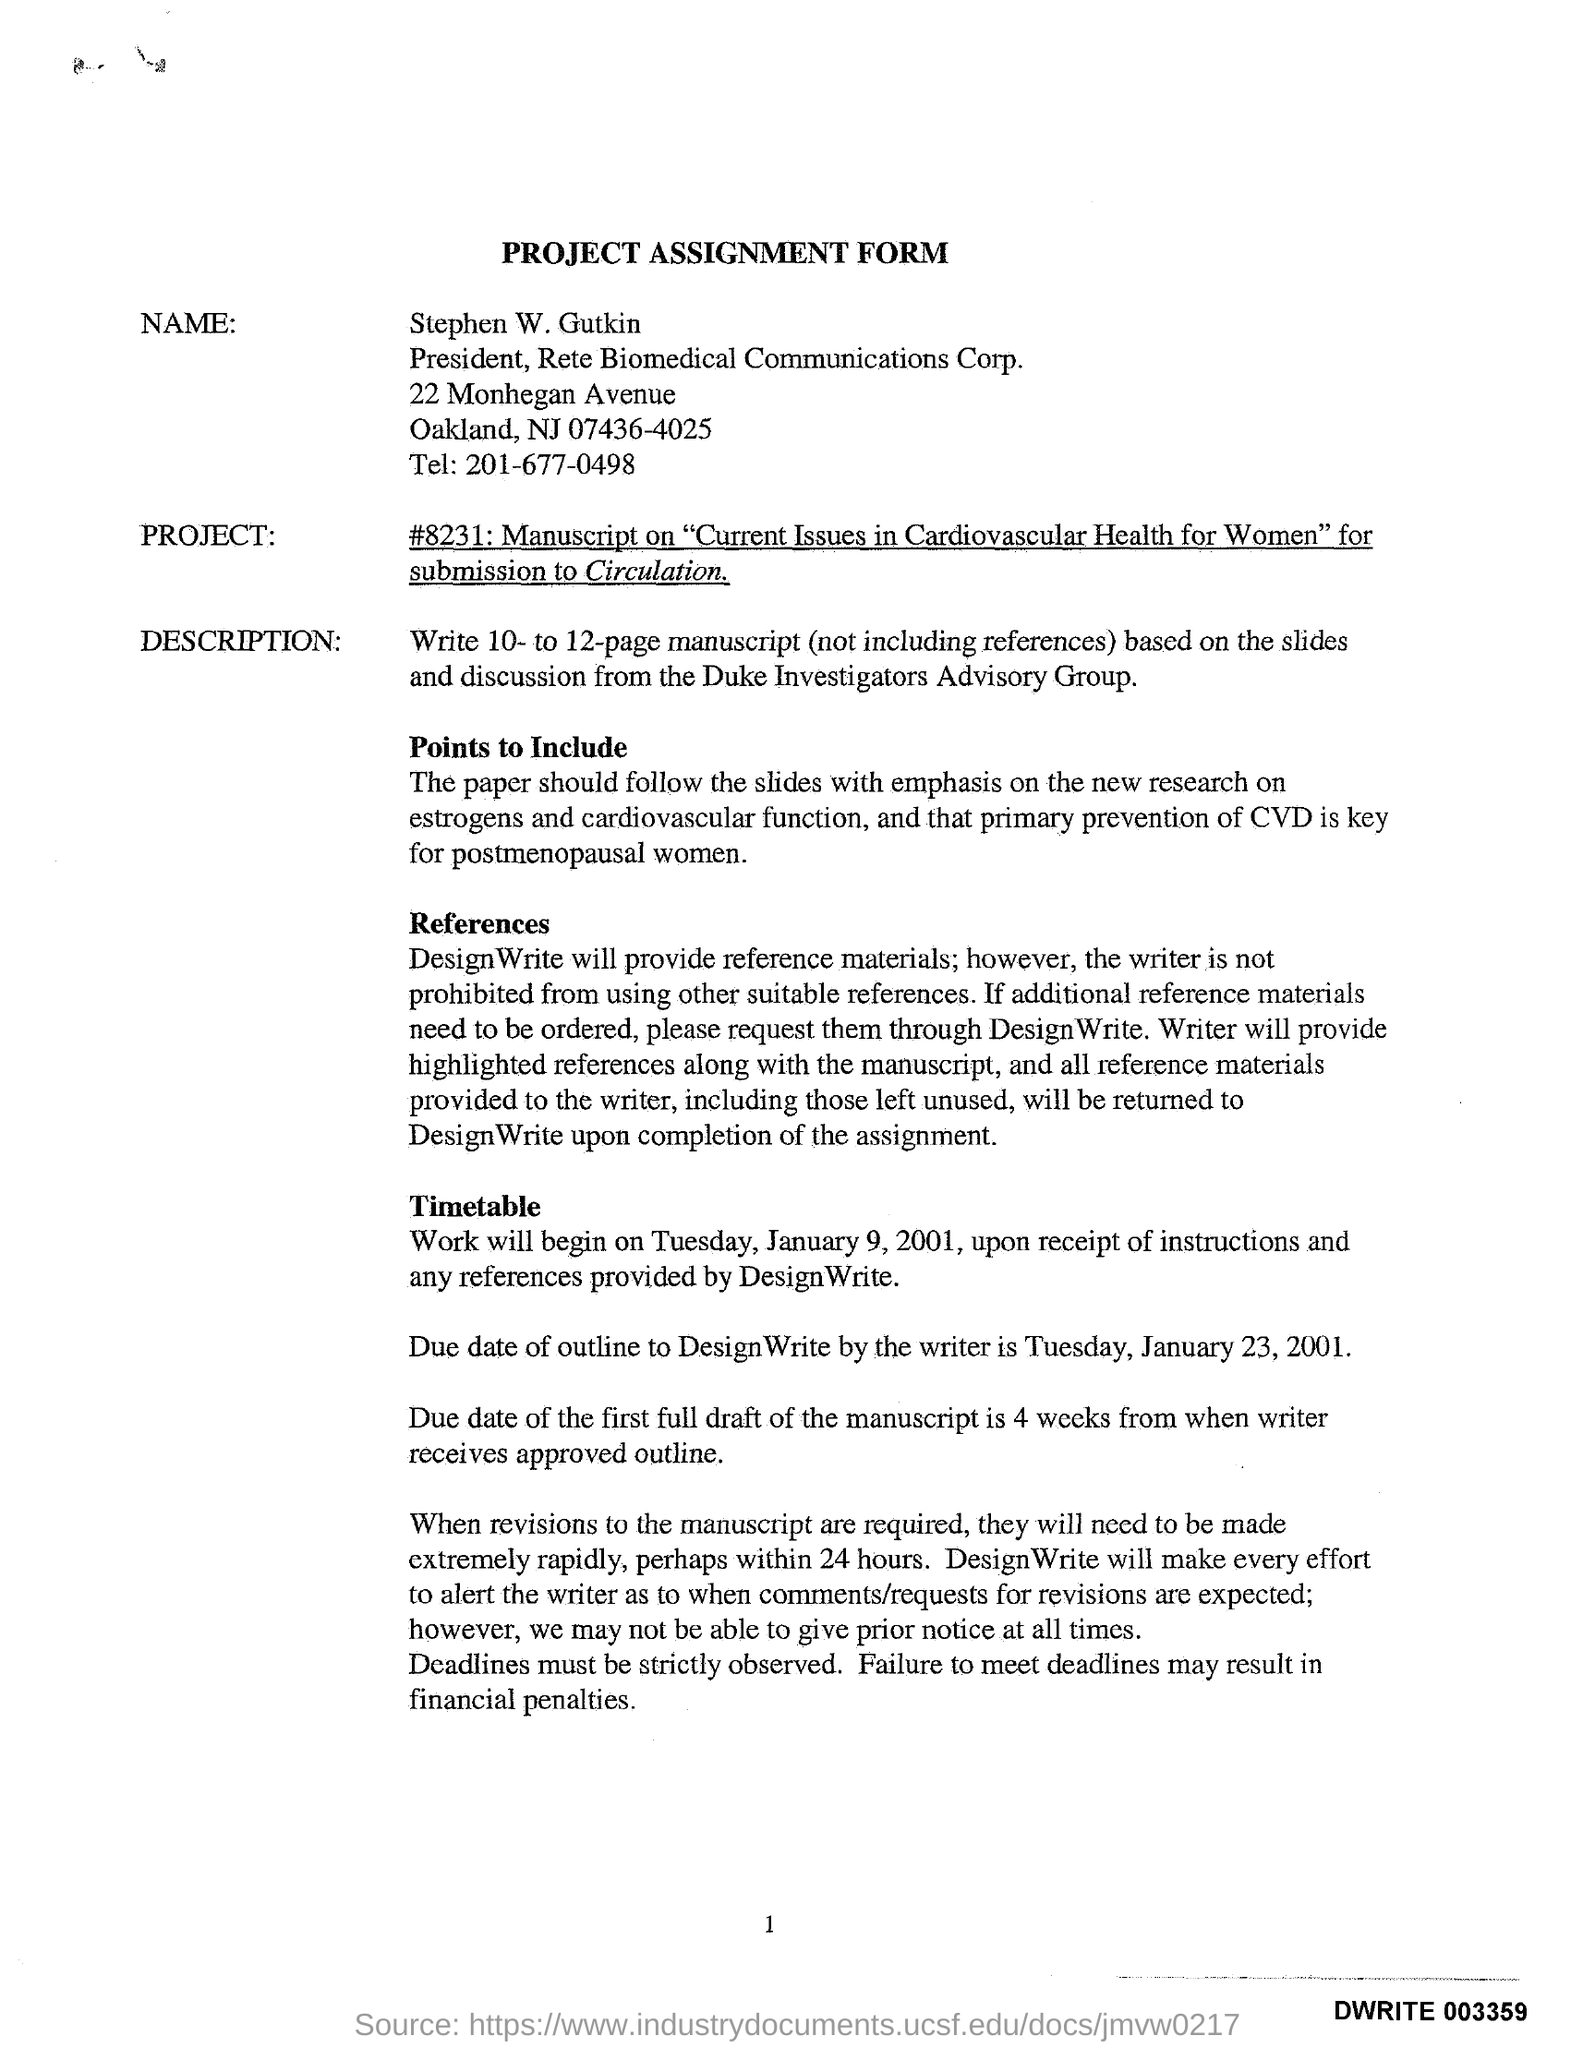List a handful of essential elements in this visual. Failing to meet deadlines may result in financial penalties. The due date for the first full draft of the manuscript is four weeks from the date of this message. The telephone number provided in the assignment form is 201-677-0498. The due date for the outline mentioned in the assignment form is Tuesday, January 23, 2001. The name of the person who completed the project assignment form is Stephen W. Gutkin. 